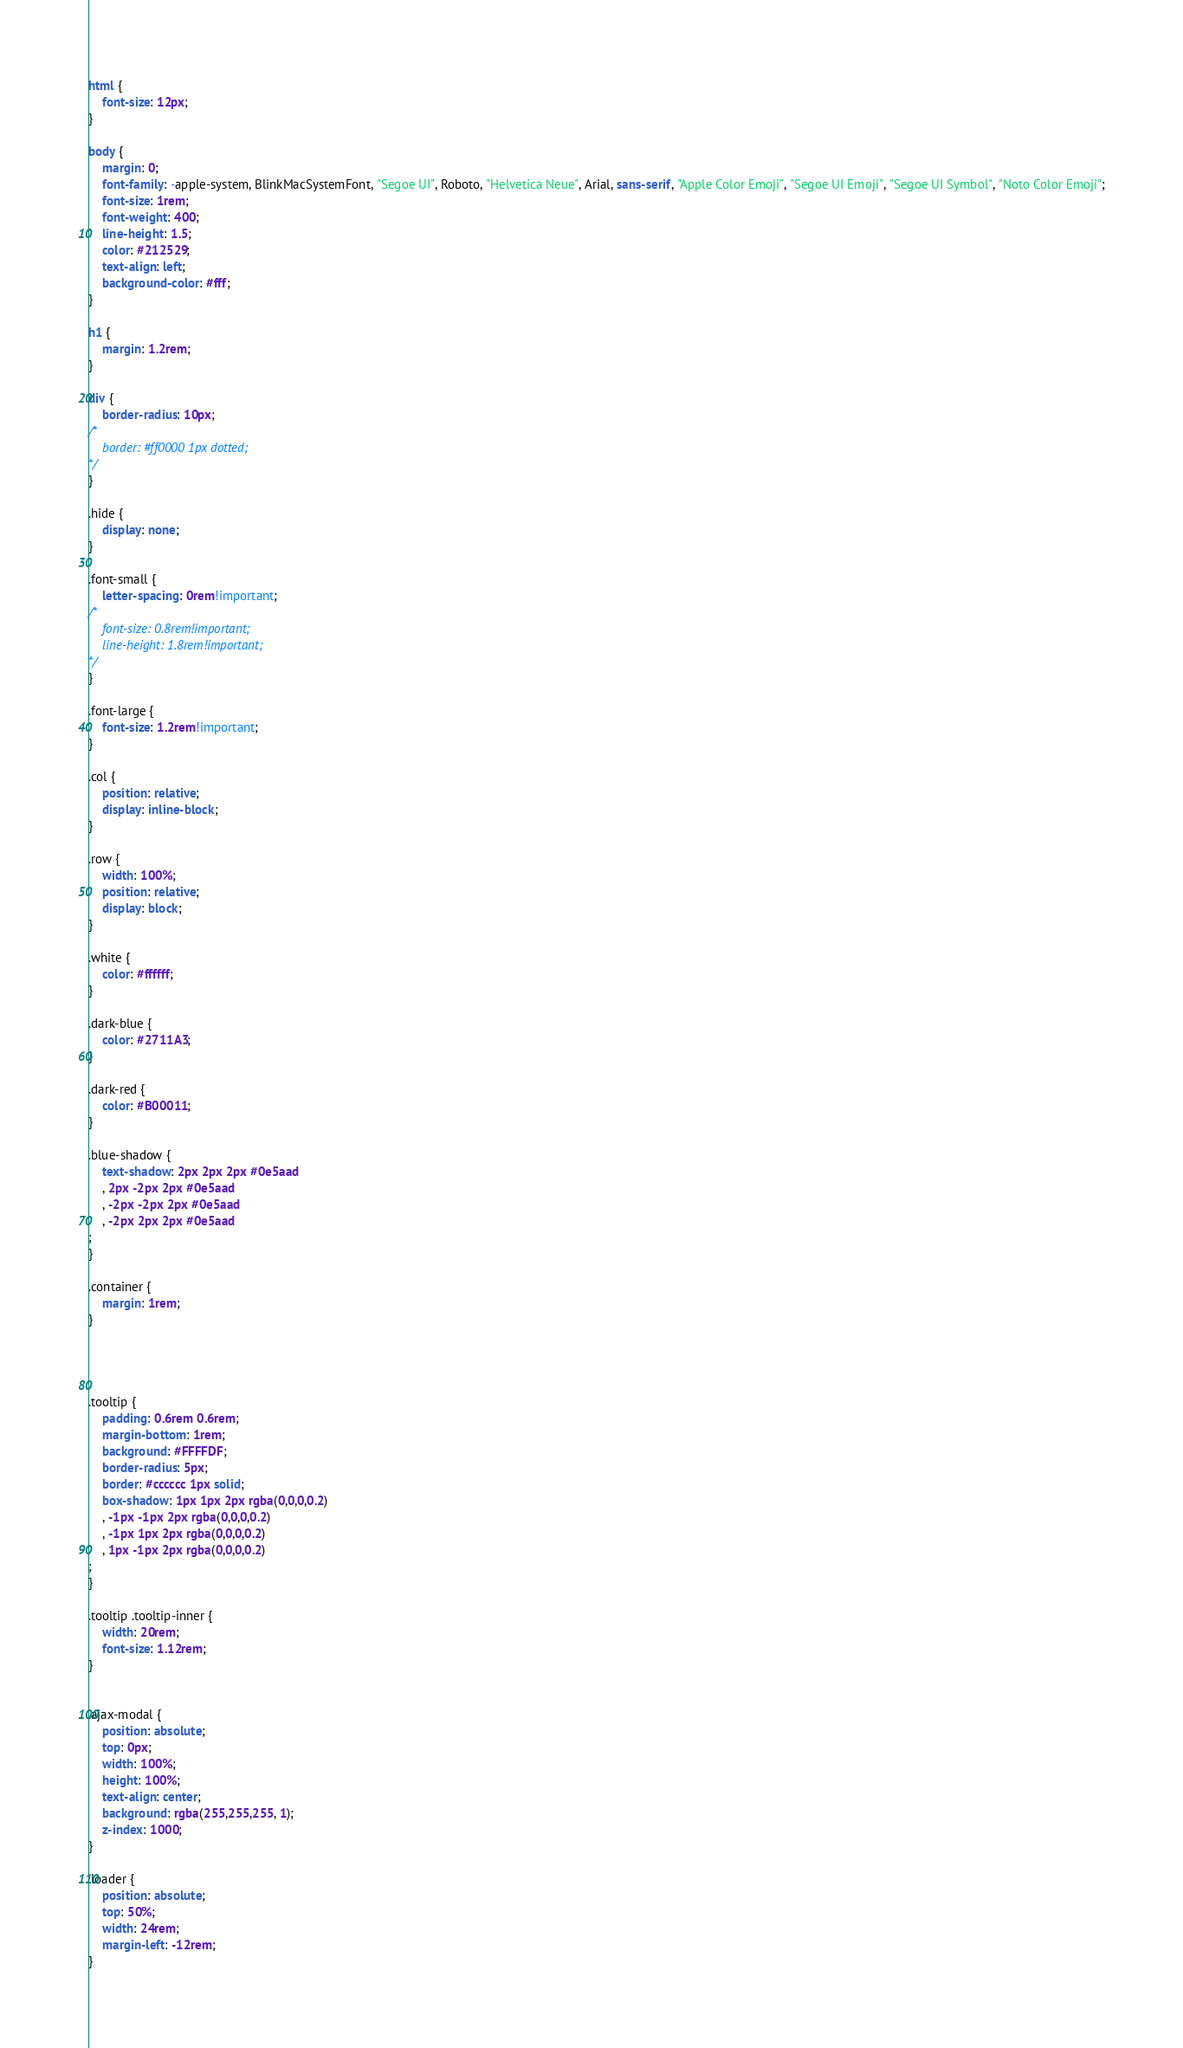Convert code to text. <code><loc_0><loc_0><loc_500><loc_500><_CSS_>html {
	font-size: 12px;
}

body {
	margin: 0;
	font-family: -apple-system, BlinkMacSystemFont, "Segoe UI", Roboto, "Helvetica Neue", Arial, sans-serif, "Apple Color Emoji", "Segoe UI Emoji", "Segoe UI Symbol", "Noto Color Emoji";
	font-size: 1rem;
	font-weight: 400;
	line-height: 1.5;
	color: #212529;
	text-align: left;
	background-color: #fff;
}

h1 {
	margin: 1.2rem;
}

div {
	border-radius: 10px;
/*
	border: #ff0000 1px dotted;
*/
}

.hide {
	display: none;
}

.font-small {
	letter-spacing: 0rem!important;
/*
	font-size: 0.8rem!important;
	line-height: 1.8rem!important;
*/
}

.font-large {
	font-size: 1.2rem!important;
}

.col {
	position: relative;
	display: inline-block;
}

.row {
	width: 100%;
	position: relative;
	display: block;
}

.white {
	color: #ffffff;
}

.dark-blue {
	color: #2711A3;
}

.dark-red {
	color: #B00011;
}

.blue-shadow {
	text-shadow: 2px 2px 2px #0e5aad
	, 2px -2px 2px #0e5aad
	, -2px -2px 2px #0e5aad
	, -2px 2px 2px #0e5aad
;
}

.container {
	margin: 1rem;
}




.tooltip {
	padding: 0.6rem 0.6rem;
	margin-bottom: 1rem;
	background: #FFFFDF;
	border-radius: 5px;
	border: #cccccc 1px solid;
	box-shadow: 1px 1px 2px rgba(0,0,0,0.2)
	, -1px -1px 2px rgba(0,0,0,0.2)
	, -1px 1px 2px rgba(0,0,0,0.2)
	, 1px -1px 2px rgba(0,0,0,0.2)
;
}

.tooltip .tooltip-inner {
	width: 20rem;
	font-size: 1.12rem;
}


.ajax-modal {
	position: absolute;
	top: 0px;
	width: 100%;
	height: 100%;
	text-align: center;
	background: rgba(255,255,255, 1);
	z-index: 1000;
}

.loader {
	position: absolute;
	top: 50%;
	width: 24rem;
	margin-left: -12rem;
}



</code> 